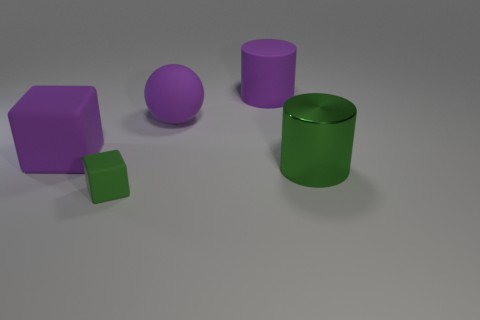Add 2 rubber cubes. How many objects exist? 7 Subtract 1 cubes. How many cubes are left? 1 Subtract all cubes. How many objects are left? 3 Subtract all gray balls. Subtract all gray cylinders. How many balls are left? 1 Subtract all blue cylinders. How many purple cubes are left? 1 Subtract all large rubber cylinders. Subtract all tiny rubber cubes. How many objects are left? 3 Add 3 big matte blocks. How many big matte blocks are left? 4 Add 4 small matte balls. How many small matte balls exist? 4 Subtract 0 blue spheres. How many objects are left? 5 